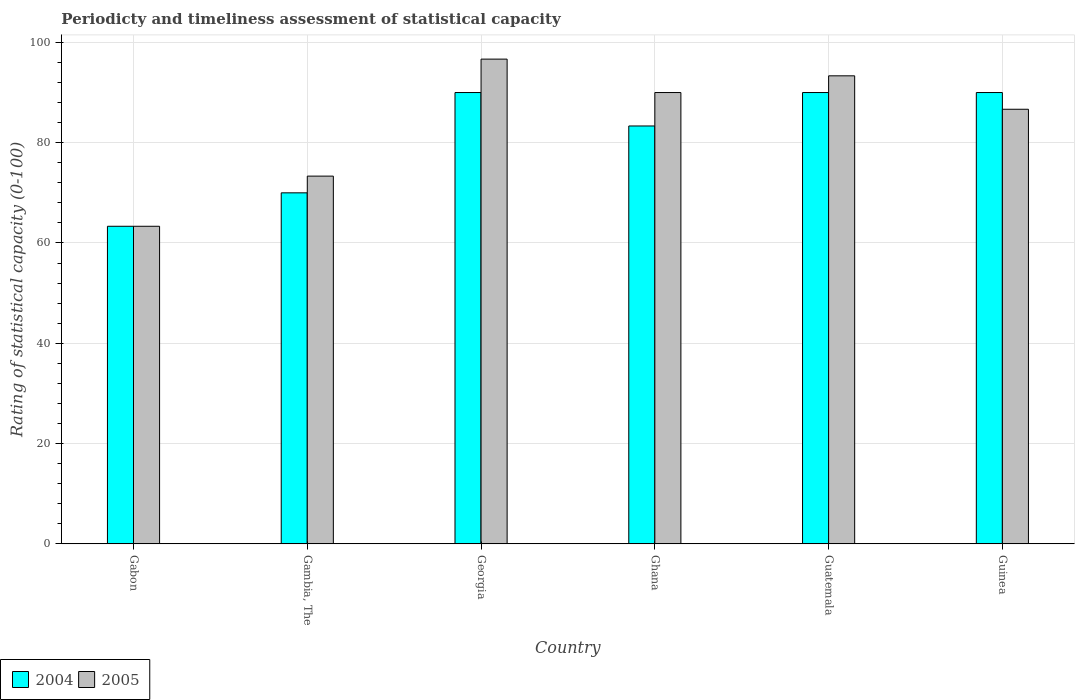How many different coloured bars are there?
Keep it short and to the point. 2. How many groups of bars are there?
Offer a terse response. 6. Are the number of bars on each tick of the X-axis equal?
Your response must be concise. Yes. Across all countries, what is the minimum rating of statistical capacity in 2004?
Provide a short and direct response. 63.33. In which country was the rating of statistical capacity in 2005 maximum?
Give a very brief answer. Georgia. In which country was the rating of statistical capacity in 2005 minimum?
Offer a terse response. Gabon. What is the total rating of statistical capacity in 2005 in the graph?
Keep it short and to the point. 503.33. What is the difference between the rating of statistical capacity in 2005 in Ghana and that in Guinea?
Your answer should be very brief. 3.33. What is the difference between the rating of statistical capacity in 2004 in Ghana and the rating of statistical capacity in 2005 in Guinea?
Give a very brief answer. -3.33. What is the average rating of statistical capacity in 2004 per country?
Your answer should be very brief. 81.11. What is the difference between the rating of statistical capacity of/in 2004 and rating of statistical capacity of/in 2005 in Gambia, The?
Offer a very short reply. -3.33. What is the ratio of the rating of statistical capacity in 2005 in Gabon to that in Guatemala?
Offer a terse response. 0.68. Is the difference between the rating of statistical capacity in 2004 in Gambia, The and Ghana greater than the difference between the rating of statistical capacity in 2005 in Gambia, The and Ghana?
Give a very brief answer. Yes. What is the difference between the highest and the second highest rating of statistical capacity in 2005?
Provide a short and direct response. 6.67. What is the difference between the highest and the lowest rating of statistical capacity in 2005?
Your answer should be very brief. 33.33. What does the 1st bar from the left in Guatemala represents?
Your answer should be very brief. 2004. How many bars are there?
Your answer should be very brief. 12. Are all the bars in the graph horizontal?
Your answer should be very brief. No. How many countries are there in the graph?
Your answer should be compact. 6. What is the difference between two consecutive major ticks on the Y-axis?
Provide a short and direct response. 20. Are the values on the major ticks of Y-axis written in scientific E-notation?
Offer a very short reply. No. How many legend labels are there?
Ensure brevity in your answer.  2. How are the legend labels stacked?
Offer a very short reply. Horizontal. What is the title of the graph?
Keep it short and to the point. Periodicty and timeliness assessment of statistical capacity. Does "1976" appear as one of the legend labels in the graph?
Give a very brief answer. No. What is the label or title of the X-axis?
Your answer should be very brief. Country. What is the label or title of the Y-axis?
Offer a terse response. Rating of statistical capacity (0-100). What is the Rating of statistical capacity (0-100) of 2004 in Gabon?
Your answer should be very brief. 63.33. What is the Rating of statistical capacity (0-100) of 2005 in Gabon?
Your answer should be very brief. 63.33. What is the Rating of statistical capacity (0-100) of 2004 in Gambia, The?
Offer a very short reply. 70. What is the Rating of statistical capacity (0-100) in 2005 in Gambia, The?
Ensure brevity in your answer.  73.33. What is the Rating of statistical capacity (0-100) in 2004 in Georgia?
Keep it short and to the point. 90. What is the Rating of statistical capacity (0-100) in 2005 in Georgia?
Your answer should be compact. 96.67. What is the Rating of statistical capacity (0-100) of 2004 in Ghana?
Provide a short and direct response. 83.33. What is the Rating of statistical capacity (0-100) in 2005 in Guatemala?
Provide a succinct answer. 93.33. What is the Rating of statistical capacity (0-100) in 2005 in Guinea?
Provide a succinct answer. 86.67. Across all countries, what is the maximum Rating of statistical capacity (0-100) in 2005?
Your answer should be very brief. 96.67. Across all countries, what is the minimum Rating of statistical capacity (0-100) in 2004?
Offer a very short reply. 63.33. Across all countries, what is the minimum Rating of statistical capacity (0-100) of 2005?
Keep it short and to the point. 63.33. What is the total Rating of statistical capacity (0-100) in 2004 in the graph?
Make the answer very short. 486.67. What is the total Rating of statistical capacity (0-100) of 2005 in the graph?
Give a very brief answer. 503.33. What is the difference between the Rating of statistical capacity (0-100) of 2004 in Gabon and that in Gambia, The?
Your answer should be very brief. -6.67. What is the difference between the Rating of statistical capacity (0-100) in 2005 in Gabon and that in Gambia, The?
Provide a succinct answer. -10. What is the difference between the Rating of statistical capacity (0-100) in 2004 in Gabon and that in Georgia?
Your answer should be very brief. -26.67. What is the difference between the Rating of statistical capacity (0-100) of 2005 in Gabon and that in Georgia?
Offer a terse response. -33.33. What is the difference between the Rating of statistical capacity (0-100) in 2004 in Gabon and that in Ghana?
Make the answer very short. -20. What is the difference between the Rating of statistical capacity (0-100) in 2005 in Gabon and that in Ghana?
Make the answer very short. -26.67. What is the difference between the Rating of statistical capacity (0-100) of 2004 in Gabon and that in Guatemala?
Your response must be concise. -26.67. What is the difference between the Rating of statistical capacity (0-100) in 2004 in Gabon and that in Guinea?
Provide a succinct answer. -26.67. What is the difference between the Rating of statistical capacity (0-100) of 2005 in Gabon and that in Guinea?
Your answer should be compact. -23.33. What is the difference between the Rating of statistical capacity (0-100) in 2004 in Gambia, The and that in Georgia?
Ensure brevity in your answer.  -20. What is the difference between the Rating of statistical capacity (0-100) in 2005 in Gambia, The and that in Georgia?
Your response must be concise. -23.33. What is the difference between the Rating of statistical capacity (0-100) in 2004 in Gambia, The and that in Ghana?
Offer a very short reply. -13.33. What is the difference between the Rating of statistical capacity (0-100) in 2005 in Gambia, The and that in Ghana?
Provide a short and direct response. -16.67. What is the difference between the Rating of statistical capacity (0-100) of 2005 in Gambia, The and that in Guinea?
Provide a short and direct response. -13.33. What is the difference between the Rating of statistical capacity (0-100) in 2004 in Georgia and that in Ghana?
Provide a short and direct response. 6.67. What is the difference between the Rating of statistical capacity (0-100) of 2004 in Georgia and that in Guatemala?
Provide a succinct answer. 0. What is the difference between the Rating of statistical capacity (0-100) of 2005 in Georgia and that in Guatemala?
Provide a short and direct response. 3.33. What is the difference between the Rating of statistical capacity (0-100) in 2004 in Georgia and that in Guinea?
Offer a very short reply. 0. What is the difference between the Rating of statistical capacity (0-100) in 2005 in Georgia and that in Guinea?
Give a very brief answer. 10. What is the difference between the Rating of statistical capacity (0-100) in 2004 in Ghana and that in Guatemala?
Offer a very short reply. -6.67. What is the difference between the Rating of statistical capacity (0-100) of 2005 in Ghana and that in Guatemala?
Offer a very short reply. -3.33. What is the difference between the Rating of statistical capacity (0-100) in 2004 in Ghana and that in Guinea?
Offer a very short reply. -6.67. What is the difference between the Rating of statistical capacity (0-100) of 2005 in Ghana and that in Guinea?
Provide a succinct answer. 3.33. What is the difference between the Rating of statistical capacity (0-100) in 2005 in Guatemala and that in Guinea?
Provide a short and direct response. 6.67. What is the difference between the Rating of statistical capacity (0-100) of 2004 in Gabon and the Rating of statistical capacity (0-100) of 2005 in Georgia?
Ensure brevity in your answer.  -33.33. What is the difference between the Rating of statistical capacity (0-100) in 2004 in Gabon and the Rating of statistical capacity (0-100) in 2005 in Ghana?
Keep it short and to the point. -26.67. What is the difference between the Rating of statistical capacity (0-100) of 2004 in Gabon and the Rating of statistical capacity (0-100) of 2005 in Guinea?
Your answer should be very brief. -23.33. What is the difference between the Rating of statistical capacity (0-100) of 2004 in Gambia, The and the Rating of statistical capacity (0-100) of 2005 in Georgia?
Your response must be concise. -26.67. What is the difference between the Rating of statistical capacity (0-100) in 2004 in Gambia, The and the Rating of statistical capacity (0-100) in 2005 in Ghana?
Keep it short and to the point. -20. What is the difference between the Rating of statistical capacity (0-100) in 2004 in Gambia, The and the Rating of statistical capacity (0-100) in 2005 in Guatemala?
Offer a very short reply. -23.33. What is the difference between the Rating of statistical capacity (0-100) of 2004 in Gambia, The and the Rating of statistical capacity (0-100) of 2005 in Guinea?
Ensure brevity in your answer.  -16.67. What is the difference between the Rating of statistical capacity (0-100) in 2004 in Georgia and the Rating of statistical capacity (0-100) in 2005 in Guatemala?
Your response must be concise. -3.33. What is the difference between the Rating of statistical capacity (0-100) of 2004 in Ghana and the Rating of statistical capacity (0-100) of 2005 in Guinea?
Provide a short and direct response. -3.33. What is the difference between the Rating of statistical capacity (0-100) in 2004 in Guatemala and the Rating of statistical capacity (0-100) in 2005 in Guinea?
Give a very brief answer. 3.33. What is the average Rating of statistical capacity (0-100) in 2004 per country?
Your answer should be compact. 81.11. What is the average Rating of statistical capacity (0-100) in 2005 per country?
Provide a succinct answer. 83.89. What is the difference between the Rating of statistical capacity (0-100) of 2004 and Rating of statistical capacity (0-100) of 2005 in Gabon?
Make the answer very short. 0. What is the difference between the Rating of statistical capacity (0-100) in 2004 and Rating of statistical capacity (0-100) in 2005 in Georgia?
Provide a short and direct response. -6.67. What is the difference between the Rating of statistical capacity (0-100) in 2004 and Rating of statistical capacity (0-100) in 2005 in Ghana?
Give a very brief answer. -6.67. What is the difference between the Rating of statistical capacity (0-100) of 2004 and Rating of statistical capacity (0-100) of 2005 in Guatemala?
Ensure brevity in your answer.  -3.33. What is the difference between the Rating of statistical capacity (0-100) in 2004 and Rating of statistical capacity (0-100) in 2005 in Guinea?
Offer a terse response. 3.33. What is the ratio of the Rating of statistical capacity (0-100) of 2004 in Gabon to that in Gambia, The?
Provide a succinct answer. 0.9. What is the ratio of the Rating of statistical capacity (0-100) of 2005 in Gabon to that in Gambia, The?
Your response must be concise. 0.86. What is the ratio of the Rating of statistical capacity (0-100) of 2004 in Gabon to that in Georgia?
Offer a terse response. 0.7. What is the ratio of the Rating of statistical capacity (0-100) in 2005 in Gabon to that in Georgia?
Your answer should be compact. 0.66. What is the ratio of the Rating of statistical capacity (0-100) in 2004 in Gabon to that in Ghana?
Offer a terse response. 0.76. What is the ratio of the Rating of statistical capacity (0-100) in 2005 in Gabon to that in Ghana?
Give a very brief answer. 0.7. What is the ratio of the Rating of statistical capacity (0-100) of 2004 in Gabon to that in Guatemala?
Offer a very short reply. 0.7. What is the ratio of the Rating of statistical capacity (0-100) of 2005 in Gabon to that in Guatemala?
Offer a very short reply. 0.68. What is the ratio of the Rating of statistical capacity (0-100) of 2004 in Gabon to that in Guinea?
Your response must be concise. 0.7. What is the ratio of the Rating of statistical capacity (0-100) in 2005 in Gabon to that in Guinea?
Your answer should be very brief. 0.73. What is the ratio of the Rating of statistical capacity (0-100) of 2005 in Gambia, The to that in Georgia?
Your response must be concise. 0.76. What is the ratio of the Rating of statistical capacity (0-100) of 2004 in Gambia, The to that in Ghana?
Make the answer very short. 0.84. What is the ratio of the Rating of statistical capacity (0-100) of 2005 in Gambia, The to that in Ghana?
Your answer should be very brief. 0.81. What is the ratio of the Rating of statistical capacity (0-100) of 2005 in Gambia, The to that in Guatemala?
Your answer should be very brief. 0.79. What is the ratio of the Rating of statistical capacity (0-100) of 2004 in Gambia, The to that in Guinea?
Give a very brief answer. 0.78. What is the ratio of the Rating of statistical capacity (0-100) of 2005 in Gambia, The to that in Guinea?
Provide a short and direct response. 0.85. What is the ratio of the Rating of statistical capacity (0-100) of 2004 in Georgia to that in Ghana?
Provide a succinct answer. 1.08. What is the ratio of the Rating of statistical capacity (0-100) in 2005 in Georgia to that in Ghana?
Offer a terse response. 1.07. What is the ratio of the Rating of statistical capacity (0-100) of 2005 in Georgia to that in Guatemala?
Offer a terse response. 1.04. What is the ratio of the Rating of statistical capacity (0-100) of 2004 in Georgia to that in Guinea?
Keep it short and to the point. 1. What is the ratio of the Rating of statistical capacity (0-100) of 2005 in Georgia to that in Guinea?
Ensure brevity in your answer.  1.12. What is the ratio of the Rating of statistical capacity (0-100) of 2004 in Ghana to that in Guatemala?
Ensure brevity in your answer.  0.93. What is the ratio of the Rating of statistical capacity (0-100) in 2004 in Ghana to that in Guinea?
Your answer should be very brief. 0.93. What is the ratio of the Rating of statistical capacity (0-100) of 2005 in Guatemala to that in Guinea?
Offer a terse response. 1.08. What is the difference between the highest and the second highest Rating of statistical capacity (0-100) of 2004?
Provide a short and direct response. 0. What is the difference between the highest and the second highest Rating of statistical capacity (0-100) of 2005?
Ensure brevity in your answer.  3.33. What is the difference between the highest and the lowest Rating of statistical capacity (0-100) in 2004?
Provide a succinct answer. 26.67. What is the difference between the highest and the lowest Rating of statistical capacity (0-100) of 2005?
Your response must be concise. 33.33. 